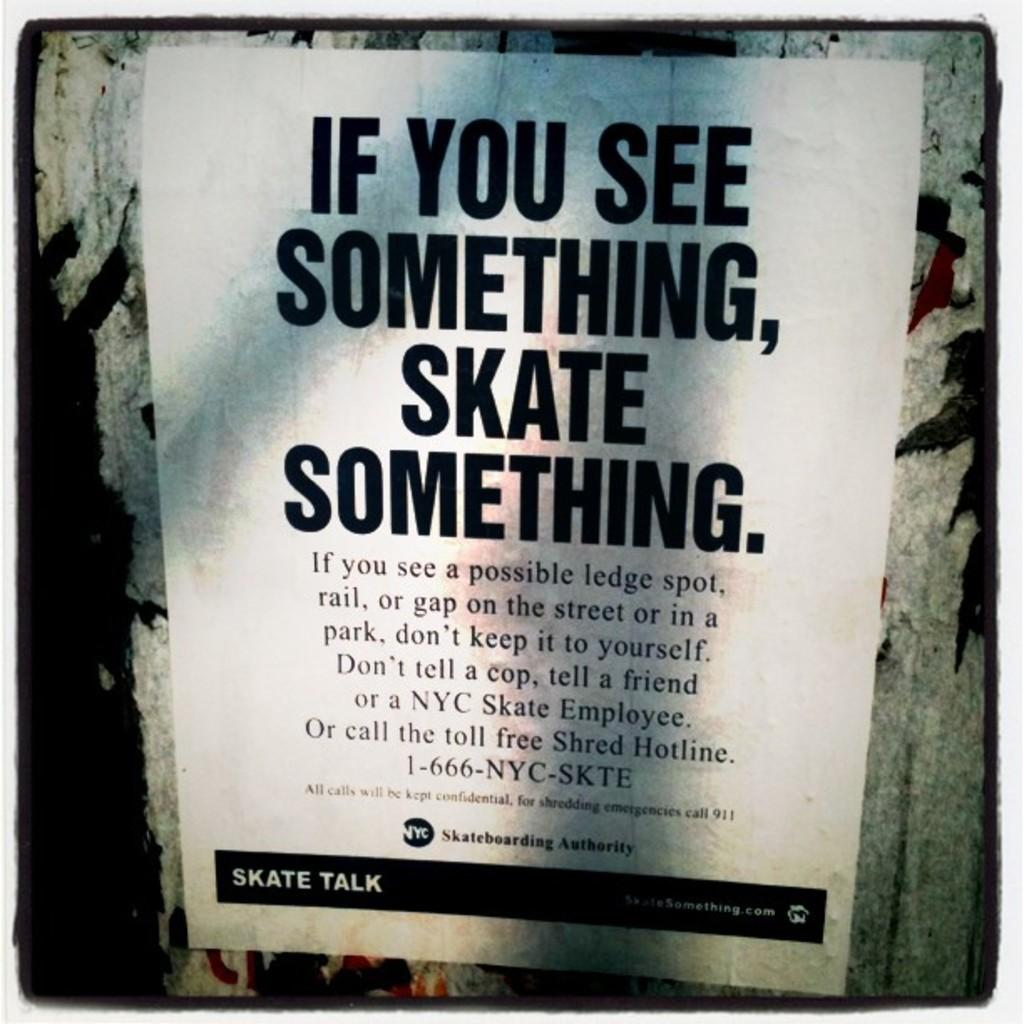<image>
Present a compact description of the photo's key features. A flyer titled If you see something say something. 